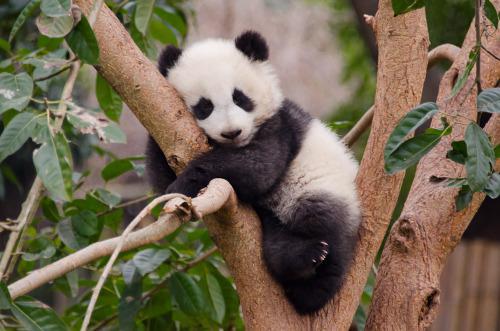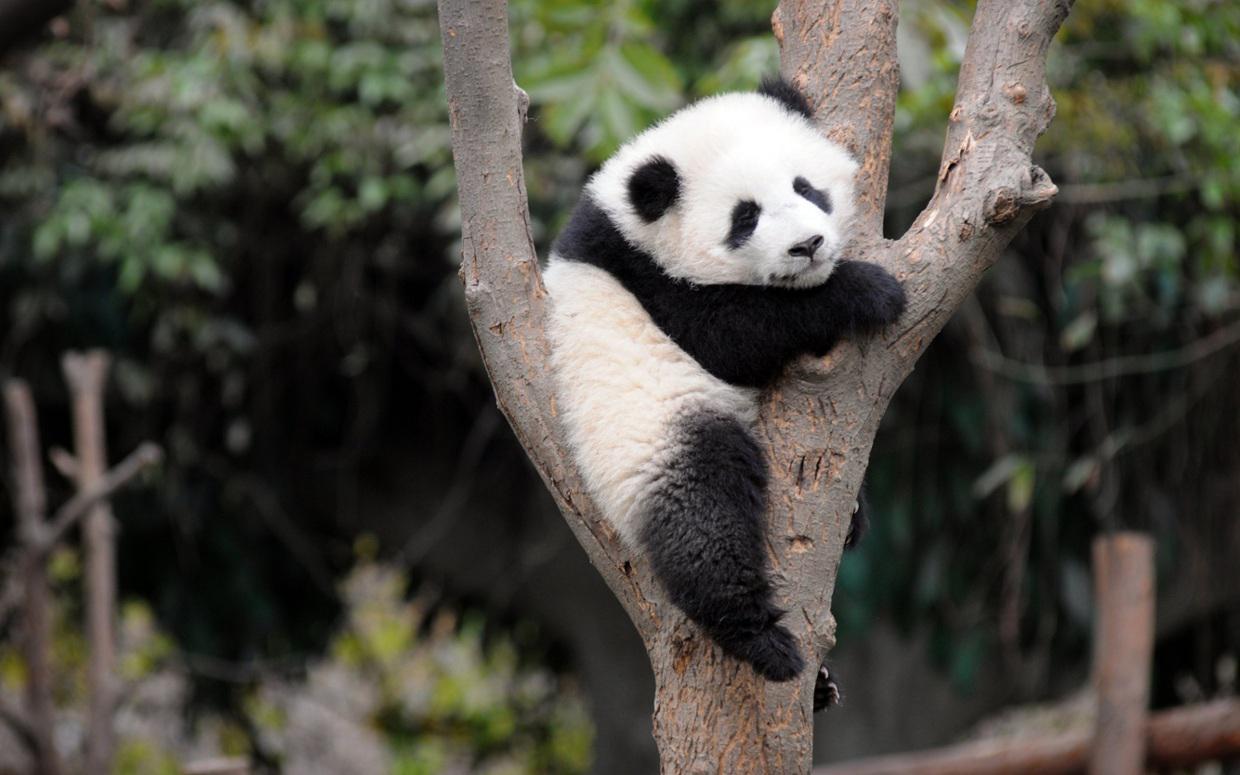The first image is the image on the left, the second image is the image on the right. Given the left and right images, does the statement "Each image shows one panda perched off the ground in something tree-like, and at least one image shows a panda with front paws around a forking tree limb." hold true? Answer yes or no. Yes. The first image is the image on the left, the second image is the image on the right. For the images displayed, is the sentence "Each image features a panda in a tree" factually correct? Answer yes or no. Yes. 